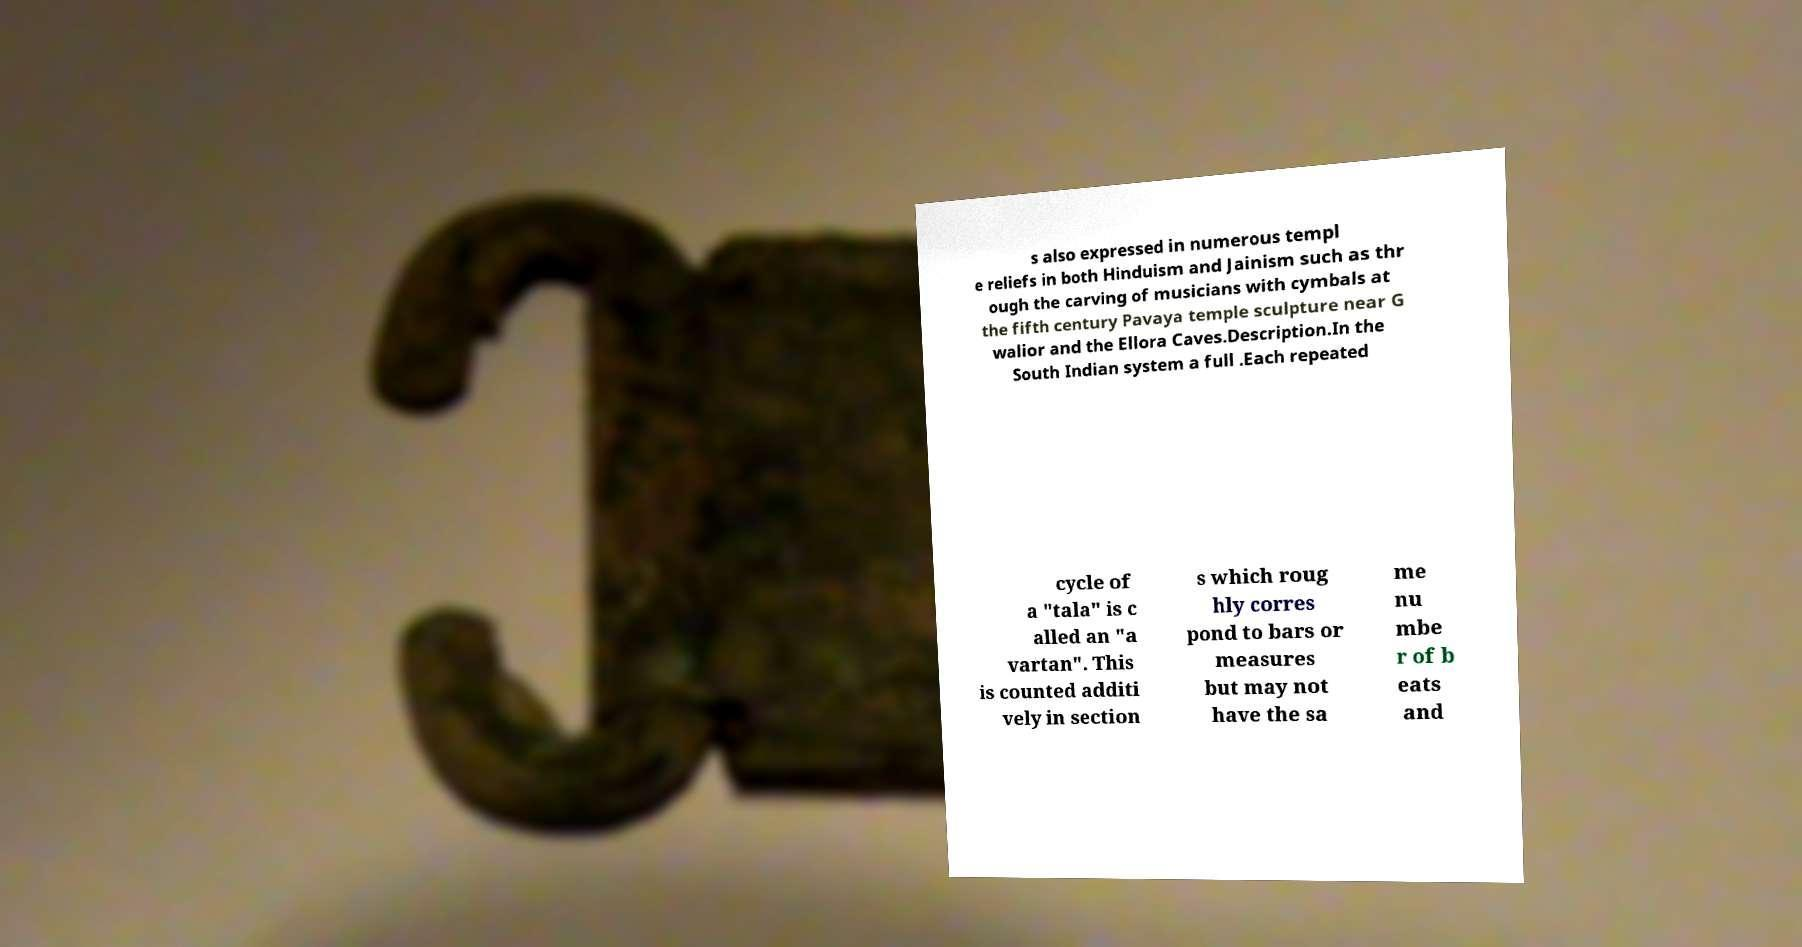Please read and relay the text visible in this image. What does it say? s also expressed in numerous templ e reliefs in both Hinduism and Jainism such as thr ough the carving of musicians with cymbals at the fifth century Pavaya temple sculpture near G walior and the Ellora Caves.Description.In the South Indian system a full .Each repeated cycle of a "tala" is c alled an "a vartan". This is counted additi vely in section s which roug hly corres pond to bars or measures but may not have the sa me nu mbe r of b eats and 